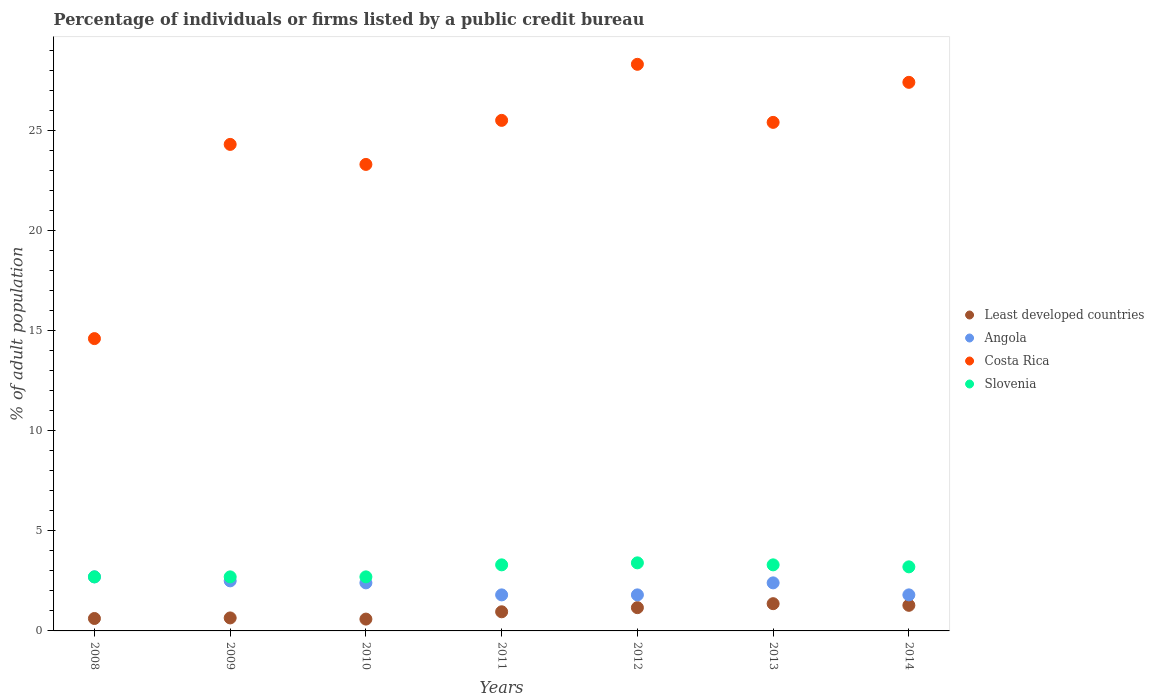How many different coloured dotlines are there?
Offer a very short reply. 4. Is the number of dotlines equal to the number of legend labels?
Keep it short and to the point. Yes. What is the percentage of population listed by a public credit bureau in Slovenia in 2009?
Provide a succinct answer. 2.7. Across all years, what is the maximum percentage of population listed by a public credit bureau in Slovenia?
Give a very brief answer. 3.4. Across all years, what is the minimum percentage of population listed by a public credit bureau in Slovenia?
Provide a succinct answer. 2.7. In which year was the percentage of population listed by a public credit bureau in Slovenia minimum?
Provide a short and direct response. 2008. What is the total percentage of population listed by a public credit bureau in Least developed countries in the graph?
Your answer should be compact. 6.62. What is the difference between the percentage of population listed by a public credit bureau in Slovenia in 2008 and that in 2012?
Your answer should be compact. -0.7. What is the difference between the percentage of population listed by a public credit bureau in Slovenia in 2011 and the percentage of population listed by a public credit bureau in Angola in 2008?
Keep it short and to the point. 0.6. What is the average percentage of population listed by a public credit bureau in Slovenia per year?
Provide a short and direct response. 3.04. In the year 2009, what is the difference between the percentage of population listed by a public credit bureau in Angola and percentage of population listed by a public credit bureau in Least developed countries?
Provide a short and direct response. 1.85. In how many years, is the percentage of population listed by a public credit bureau in Least developed countries greater than 5 %?
Provide a succinct answer. 0. What is the ratio of the percentage of population listed by a public credit bureau in Slovenia in 2011 to that in 2014?
Give a very brief answer. 1.03. Is the percentage of population listed by a public credit bureau in Angola in 2011 less than that in 2014?
Offer a terse response. No. Is the difference between the percentage of population listed by a public credit bureau in Angola in 2010 and 2014 greater than the difference between the percentage of population listed by a public credit bureau in Least developed countries in 2010 and 2014?
Provide a succinct answer. Yes. What is the difference between the highest and the second highest percentage of population listed by a public credit bureau in Costa Rica?
Ensure brevity in your answer.  0.9. What is the difference between the highest and the lowest percentage of population listed by a public credit bureau in Least developed countries?
Offer a very short reply. 0.77. Is it the case that in every year, the sum of the percentage of population listed by a public credit bureau in Angola and percentage of population listed by a public credit bureau in Costa Rica  is greater than the sum of percentage of population listed by a public credit bureau in Least developed countries and percentage of population listed by a public credit bureau in Slovenia?
Offer a terse response. Yes. Is it the case that in every year, the sum of the percentage of population listed by a public credit bureau in Angola and percentage of population listed by a public credit bureau in Costa Rica  is greater than the percentage of population listed by a public credit bureau in Slovenia?
Provide a succinct answer. Yes. Does the percentage of population listed by a public credit bureau in Slovenia monotonically increase over the years?
Offer a terse response. No. How many dotlines are there?
Provide a short and direct response. 4. How many years are there in the graph?
Provide a short and direct response. 7. What is the difference between two consecutive major ticks on the Y-axis?
Give a very brief answer. 5. Does the graph contain grids?
Keep it short and to the point. No. How are the legend labels stacked?
Provide a succinct answer. Vertical. What is the title of the graph?
Ensure brevity in your answer.  Percentage of individuals or firms listed by a public credit bureau. What is the label or title of the X-axis?
Offer a terse response. Years. What is the label or title of the Y-axis?
Provide a short and direct response. % of adult population. What is the % of adult population of Least developed countries in 2008?
Make the answer very short. 0.62. What is the % of adult population in Least developed countries in 2009?
Provide a short and direct response. 0.65. What is the % of adult population in Angola in 2009?
Make the answer very short. 2.5. What is the % of adult population of Costa Rica in 2009?
Make the answer very short. 24.3. What is the % of adult population in Slovenia in 2009?
Make the answer very short. 2.7. What is the % of adult population of Least developed countries in 2010?
Make the answer very short. 0.59. What is the % of adult population of Angola in 2010?
Provide a short and direct response. 2.4. What is the % of adult population in Costa Rica in 2010?
Give a very brief answer. 23.3. What is the % of adult population of Least developed countries in 2011?
Offer a terse response. 0.96. What is the % of adult population of Angola in 2011?
Your answer should be compact. 1.8. What is the % of adult population in Costa Rica in 2011?
Offer a terse response. 25.5. What is the % of adult population of Least developed countries in 2012?
Offer a very short reply. 1.16. What is the % of adult population of Costa Rica in 2012?
Your response must be concise. 28.3. What is the % of adult population of Least developed countries in 2013?
Your response must be concise. 1.36. What is the % of adult population in Costa Rica in 2013?
Offer a very short reply. 25.4. What is the % of adult population in Slovenia in 2013?
Give a very brief answer. 3.3. What is the % of adult population of Least developed countries in 2014?
Keep it short and to the point. 1.28. What is the % of adult population in Costa Rica in 2014?
Offer a terse response. 27.4. What is the % of adult population in Slovenia in 2014?
Your answer should be compact. 3.2. Across all years, what is the maximum % of adult population in Least developed countries?
Give a very brief answer. 1.36. Across all years, what is the maximum % of adult population of Costa Rica?
Give a very brief answer. 28.3. Across all years, what is the maximum % of adult population of Slovenia?
Your answer should be very brief. 3.4. Across all years, what is the minimum % of adult population in Least developed countries?
Offer a terse response. 0.59. Across all years, what is the minimum % of adult population in Costa Rica?
Ensure brevity in your answer.  14.6. Across all years, what is the minimum % of adult population of Slovenia?
Your answer should be very brief. 2.7. What is the total % of adult population of Least developed countries in the graph?
Offer a terse response. 6.62. What is the total % of adult population of Angola in the graph?
Offer a very short reply. 15.4. What is the total % of adult population in Costa Rica in the graph?
Offer a very short reply. 168.8. What is the total % of adult population in Slovenia in the graph?
Offer a terse response. 21.3. What is the difference between the % of adult population of Least developed countries in 2008 and that in 2009?
Ensure brevity in your answer.  -0.03. What is the difference between the % of adult population in Angola in 2008 and that in 2009?
Your answer should be compact. 0.2. What is the difference between the % of adult population of Slovenia in 2008 and that in 2009?
Provide a short and direct response. 0. What is the difference between the % of adult population of Least developed countries in 2008 and that in 2010?
Make the answer very short. 0.03. What is the difference between the % of adult population in Angola in 2008 and that in 2010?
Offer a terse response. 0.3. What is the difference between the % of adult population of Costa Rica in 2008 and that in 2010?
Your answer should be compact. -8.7. What is the difference between the % of adult population in Slovenia in 2008 and that in 2010?
Your answer should be very brief. 0. What is the difference between the % of adult population in Least developed countries in 2008 and that in 2011?
Your answer should be very brief. -0.33. What is the difference between the % of adult population in Least developed countries in 2008 and that in 2012?
Provide a short and direct response. -0.54. What is the difference between the % of adult population of Angola in 2008 and that in 2012?
Ensure brevity in your answer.  0.9. What is the difference between the % of adult population in Costa Rica in 2008 and that in 2012?
Offer a very short reply. -13.7. What is the difference between the % of adult population in Least developed countries in 2008 and that in 2013?
Make the answer very short. -0.74. What is the difference between the % of adult population of Angola in 2008 and that in 2013?
Offer a terse response. 0.3. What is the difference between the % of adult population of Least developed countries in 2008 and that in 2014?
Offer a very short reply. -0.66. What is the difference between the % of adult population of Angola in 2008 and that in 2014?
Ensure brevity in your answer.  0.9. What is the difference between the % of adult population in Costa Rica in 2008 and that in 2014?
Provide a succinct answer. -12.8. What is the difference between the % of adult population of Slovenia in 2008 and that in 2014?
Your answer should be very brief. -0.5. What is the difference between the % of adult population of Least developed countries in 2009 and that in 2010?
Keep it short and to the point. 0.06. What is the difference between the % of adult population of Angola in 2009 and that in 2010?
Make the answer very short. 0.1. What is the difference between the % of adult population in Slovenia in 2009 and that in 2010?
Provide a succinct answer. 0. What is the difference between the % of adult population of Least developed countries in 2009 and that in 2011?
Keep it short and to the point. -0.31. What is the difference between the % of adult population in Costa Rica in 2009 and that in 2011?
Your answer should be very brief. -1.2. What is the difference between the % of adult population in Slovenia in 2009 and that in 2011?
Your response must be concise. -0.6. What is the difference between the % of adult population in Least developed countries in 2009 and that in 2012?
Give a very brief answer. -0.51. What is the difference between the % of adult population of Costa Rica in 2009 and that in 2012?
Keep it short and to the point. -4. What is the difference between the % of adult population in Slovenia in 2009 and that in 2012?
Offer a terse response. -0.7. What is the difference between the % of adult population of Least developed countries in 2009 and that in 2013?
Your answer should be very brief. -0.71. What is the difference between the % of adult population of Costa Rica in 2009 and that in 2013?
Make the answer very short. -1.1. What is the difference between the % of adult population of Slovenia in 2009 and that in 2013?
Make the answer very short. -0.6. What is the difference between the % of adult population of Least developed countries in 2009 and that in 2014?
Offer a terse response. -0.63. What is the difference between the % of adult population of Slovenia in 2009 and that in 2014?
Your response must be concise. -0.5. What is the difference between the % of adult population of Least developed countries in 2010 and that in 2011?
Offer a very short reply. -0.37. What is the difference between the % of adult population in Angola in 2010 and that in 2011?
Offer a terse response. 0.6. What is the difference between the % of adult population of Least developed countries in 2010 and that in 2012?
Give a very brief answer. -0.57. What is the difference between the % of adult population in Angola in 2010 and that in 2012?
Offer a terse response. 0.6. What is the difference between the % of adult population of Slovenia in 2010 and that in 2012?
Make the answer very short. -0.7. What is the difference between the % of adult population of Least developed countries in 2010 and that in 2013?
Your answer should be very brief. -0.77. What is the difference between the % of adult population of Least developed countries in 2010 and that in 2014?
Your answer should be very brief. -0.69. What is the difference between the % of adult population of Angola in 2010 and that in 2014?
Offer a very short reply. 0.6. What is the difference between the % of adult population of Costa Rica in 2010 and that in 2014?
Provide a short and direct response. -4.1. What is the difference between the % of adult population in Least developed countries in 2011 and that in 2012?
Keep it short and to the point. -0.21. What is the difference between the % of adult population of Costa Rica in 2011 and that in 2012?
Ensure brevity in your answer.  -2.8. What is the difference between the % of adult population of Least developed countries in 2011 and that in 2013?
Provide a short and direct response. -0.41. What is the difference between the % of adult population of Costa Rica in 2011 and that in 2013?
Provide a succinct answer. 0.1. What is the difference between the % of adult population of Slovenia in 2011 and that in 2013?
Keep it short and to the point. 0. What is the difference between the % of adult population in Least developed countries in 2011 and that in 2014?
Make the answer very short. -0.32. What is the difference between the % of adult population of Least developed countries in 2012 and that in 2013?
Your answer should be very brief. -0.2. What is the difference between the % of adult population of Slovenia in 2012 and that in 2013?
Your response must be concise. 0.1. What is the difference between the % of adult population in Least developed countries in 2012 and that in 2014?
Make the answer very short. -0.12. What is the difference between the % of adult population of Costa Rica in 2012 and that in 2014?
Provide a succinct answer. 0.9. What is the difference between the % of adult population of Least developed countries in 2013 and that in 2014?
Make the answer very short. 0.08. What is the difference between the % of adult population of Angola in 2013 and that in 2014?
Keep it short and to the point. 0.6. What is the difference between the % of adult population of Least developed countries in 2008 and the % of adult population of Angola in 2009?
Your answer should be very brief. -1.88. What is the difference between the % of adult population of Least developed countries in 2008 and the % of adult population of Costa Rica in 2009?
Your answer should be very brief. -23.68. What is the difference between the % of adult population in Least developed countries in 2008 and the % of adult population in Slovenia in 2009?
Offer a terse response. -2.08. What is the difference between the % of adult population in Angola in 2008 and the % of adult population in Costa Rica in 2009?
Give a very brief answer. -21.6. What is the difference between the % of adult population of Angola in 2008 and the % of adult population of Slovenia in 2009?
Provide a short and direct response. 0. What is the difference between the % of adult population in Least developed countries in 2008 and the % of adult population in Angola in 2010?
Your answer should be very brief. -1.78. What is the difference between the % of adult population in Least developed countries in 2008 and the % of adult population in Costa Rica in 2010?
Give a very brief answer. -22.68. What is the difference between the % of adult population in Least developed countries in 2008 and the % of adult population in Slovenia in 2010?
Offer a very short reply. -2.08. What is the difference between the % of adult population in Angola in 2008 and the % of adult population in Costa Rica in 2010?
Your response must be concise. -20.6. What is the difference between the % of adult population of Least developed countries in 2008 and the % of adult population of Angola in 2011?
Your response must be concise. -1.18. What is the difference between the % of adult population of Least developed countries in 2008 and the % of adult population of Costa Rica in 2011?
Offer a terse response. -24.88. What is the difference between the % of adult population in Least developed countries in 2008 and the % of adult population in Slovenia in 2011?
Give a very brief answer. -2.68. What is the difference between the % of adult population in Angola in 2008 and the % of adult population in Costa Rica in 2011?
Your answer should be compact. -22.8. What is the difference between the % of adult population in Angola in 2008 and the % of adult population in Slovenia in 2011?
Provide a succinct answer. -0.6. What is the difference between the % of adult population in Least developed countries in 2008 and the % of adult population in Angola in 2012?
Ensure brevity in your answer.  -1.18. What is the difference between the % of adult population in Least developed countries in 2008 and the % of adult population in Costa Rica in 2012?
Ensure brevity in your answer.  -27.68. What is the difference between the % of adult population in Least developed countries in 2008 and the % of adult population in Slovenia in 2012?
Your answer should be compact. -2.78. What is the difference between the % of adult population of Angola in 2008 and the % of adult population of Costa Rica in 2012?
Keep it short and to the point. -25.6. What is the difference between the % of adult population of Angola in 2008 and the % of adult population of Slovenia in 2012?
Ensure brevity in your answer.  -0.7. What is the difference between the % of adult population of Costa Rica in 2008 and the % of adult population of Slovenia in 2012?
Provide a succinct answer. 11.2. What is the difference between the % of adult population in Least developed countries in 2008 and the % of adult population in Angola in 2013?
Offer a very short reply. -1.78. What is the difference between the % of adult population in Least developed countries in 2008 and the % of adult population in Costa Rica in 2013?
Your answer should be compact. -24.78. What is the difference between the % of adult population of Least developed countries in 2008 and the % of adult population of Slovenia in 2013?
Offer a terse response. -2.68. What is the difference between the % of adult population of Angola in 2008 and the % of adult population of Costa Rica in 2013?
Keep it short and to the point. -22.7. What is the difference between the % of adult population of Angola in 2008 and the % of adult population of Slovenia in 2013?
Ensure brevity in your answer.  -0.6. What is the difference between the % of adult population of Costa Rica in 2008 and the % of adult population of Slovenia in 2013?
Provide a short and direct response. 11.3. What is the difference between the % of adult population of Least developed countries in 2008 and the % of adult population of Angola in 2014?
Your response must be concise. -1.18. What is the difference between the % of adult population in Least developed countries in 2008 and the % of adult population in Costa Rica in 2014?
Offer a terse response. -26.78. What is the difference between the % of adult population in Least developed countries in 2008 and the % of adult population in Slovenia in 2014?
Ensure brevity in your answer.  -2.58. What is the difference between the % of adult population in Angola in 2008 and the % of adult population in Costa Rica in 2014?
Offer a terse response. -24.7. What is the difference between the % of adult population in Angola in 2008 and the % of adult population in Slovenia in 2014?
Provide a succinct answer. -0.5. What is the difference between the % of adult population of Costa Rica in 2008 and the % of adult population of Slovenia in 2014?
Provide a short and direct response. 11.4. What is the difference between the % of adult population in Least developed countries in 2009 and the % of adult population in Angola in 2010?
Your answer should be compact. -1.75. What is the difference between the % of adult population of Least developed countries in 2009 and the % of adult population of Costa Rica in 2010?
Your response must be concise. -22.65. What is the difference between the % of adult population of Least developed countries in 2009 and the % of adult population of Slovenia in 2010?
Give a very brief answer. -2.05. What is the difference between the % of adult population in Angola in 2009 and the % of adult population in Costa Rica in 2010?
Your answer should be compact. -20.8. What is the difference between the % of adult population in Costa Rica in 2009 and the % of adult population in Slovenia in 2010?
Make the answer very short. 21.6. What is the difference between the % of adult population of Least developed countries in 2009 and the % of adult population of Angola in 2011?
Give a very brief answer. -1.15. What is the difference between the % of adult population in Least developed countries in 2009 and the % of adult population in Costa Rica in 2011?
Offer a terse response. -24.85. What is the difference between the % of adult population of Least developed countries in 2009 and the % of adult population of Slovenia in 2011?
Your response must be concise. -2.65. What is the difference between the % of adult population of Angola in 2009 and the % of adult population of Costa Rica in 2011?
Provide a short and direct response. -23. What is the difference between the % of adult population of Costa Rica in 2009 and the % of adult population of Slovenia in 2011?
Your response must be concise. 21. What is the difference between the % of adult population of Least developed countries in 2009 and the % of adult population of Angola in 2012?
Keep it short and to the point. -1.15. What is the difference between the % of adult population in Least developed countries in 2009 and the % of adult population in Costa Rica in 2012?
Provide a succinct answer. -27.65. What is the difference between the % of adult population of Least developed countries in 2009 and the % of adult population of Slovenia in 2012?
Provide a succinct answer. -2.75. What is the difference between the % of adult population of Angola in 2009 and the % of adult population of Costa Rica in 2012?
Ensure brevity in your answer.  -25.8. What is the difference between the % of adult population of Costa Rica in 2009 and the % of adult population of Slovenia in 2012?
Keep it short and to the point. 20.9. What is the difference between the % of adult population in Least developed countries in 2009 and the % of adult population in Angola in 2013?
Your answer should be very brief. -1.75. What is the difference between the % of adult population of Least developed countries in 2009 and the % of adult population of Costa Rica in 2013?
Offer a terse response. -24.75. What is the difference between the % of adult population of Least developed countries in 2009 and the % of adult population of Slovenia in 2013?
Your answer should be compact. -2.65. What is the difference between the % of adult population in Angola in 2009 and the % of adult population in Costa Rica in 2013?
Provide a short and direct response. -22.9. What is the difference between the % of adult population of Angola in 2009 and the % of adult population of Slovenia in 2013?
Your answer should be very brief. -0.8. What is the difference between the % of adult population in Least developed countries in 2009 and the % of adult population in Angola in 2014?
Your answer should be compact. -1.15. What is the difference between the % of adult population in Least developed countries in 2009 and the % of adult population in Costa Rica in 2014?
Provide a short and direct response. -26.75. What is the difference between the % of adult population of Least developed countries in 2009 and the % of adult population of Slovenia in 2014?
Your answer should be very brief. -2.55. What is the difference between the % of adult population in Angola in 2009 and the % of adult population in Costa Rica in 2014?
Provide a succinct answer. -24.9. What is the difference between the % of adult population of Costa Rica in 2009 and the % of adult population of Slovenia in 2014?
Your response must be concise. 21.1. What is the difference between the % of adult population of Least developed countries in 2010 and the % of adult population of Angola in 2011?
Your answer should be compact. -1.21. What is the difference between the % of adult population of Least developed countries in 2010 and the % of adult population of Costa Rica in 2011?
Make the answer very short. -24.91. What is the difference between the % of adult population in Least developed countries in 2010 and the % of adult population in Slovenia in 2011?
Provide a succinct answer. -2.71. What is the difference between the % of adult population in Angola in 2010 and the % of adult population in Costa Rica in 2011?
Provide a succinct answer. -23.1. What is the difference between the % of adult population of Angola in 2010 and the % of adult population of Slovenia in 2011?
Offer a very short reply. -0.9. What is the difference between the % of adult population in Costa Rica in 2010 and the % of adult population in Slovenia in 2011?
Provide a short and direct response. 20. What is the difference between the % of adult population of Least developed countries in 2010 and the % of adult population of Angola in 2012?
Your answer should be very brief. -1.21. What is the difference between the % of adult population in Least developed countries in 2010 and the % of adult population in Costa Rica in 2012?
Your response must be concise. -27.71. What is the difference between the % of adult population of Least developed countries in 2010 and the % of adult population of Slovenia in 2012?
Provide a succinct answer. -2.81. What is the difference between the % of adult population in Angola in 2010 and the % of adult population in Costa Rica in 2012?
Provide a succinct answer. -25.9. What is the difference between the % of adult population of Angola in 2010 and the % of adult population of Slovenia in 2012?
Your answer should be compact. -1. What is the difference between the % of adult population of Least developed countries in 2010 and the % of adult population of Angola in 2013?
Offer a terse response. -1.81. What is the difference between the % of adult population in Least developed countries in 2010 and the % of adult population in Costa Rica in 2013?
Offer a very short reply. -24.81. What is the difference between the % of adult population in Least developed countries in 2010 and the % of adult population in Slovenia in 2013?
Offer a terse response. -2.71. What is the difference between the % of adult population in Least developed countries in 2010 and the % of adult population in Angola in 2014?
Provide a short and direct response. -1.21. What is the difference between the % of adult population in Least developed countries in 2010 and the % of adult population in Costa Rica in 2014?
Your answer should be very brief. -26.81. What is the difference between the % of adult population of Least developed countries in 2010 and the % of adult population of Slovenia in 2014?
Give a very brief answer. -2.61. What is the difference between the % of adult population of Angola in 2010 and the % of adult population of Costa Rica in 2014?
Give a very brief answer. -25. What is the difference between the % of adult population of Angola in 2010 and the % of adult population of Slovenia in 2014?
Provide a short and direct response. -0.8. What is the difference between the % of adult population of Costa Rica in 2010 and the % of adult population of Slovenia in 2014?
Provide a short and direct response. 20.1. What is the difference between the % of adult population in Least developed countries in 2011 and the % of adult population in Angola in 2012?
Ensure brevity in your answer.  -0.84. What is the difference between the % of adult population of Least developed countries in 2011 and the % of adult population of Costa Rica in 2012?
Keep it short and to the point. -27.34. What is the difference between the % of adult population of Least developed countries in 2011 and the % of adult population of Slovenia in 2012?
Provide a succinct answer. -2.44. What is the difference between the % of adult population in Angola in 2011 and the % of adult population in Costa Rica in 2012?
Make the answer very short. -26.5. What is the difference between the % of adult population in Costa Rica in 2011 and the % of adult population in Slovenia in 2012?
Make the answer very short. 22.1. What is the difference between the % of adult population of Least developed countries in 2011 and the % of adult population of Angola in 2013?
Make the answer very short. -1.44. What is the difference between the % of adult population in Least developed countries in 2011 and the % of adult population in Costa Rica in 2013?
Your answer should be very brief. -24.44. What is the difference between the % of adult population in Least developed countries in 2011 and the % of adult population in Slovenia in 2013?
Offer a terse response. -2.34. What is the difference between the % of adult population of Angola in 2011 and the % of adult population of Costa Rica in 2013?
Keep it short and to the point. -23.6. What is the difference between the % of adult population in Costa Rica in 2011 and the % of adult population in Slovenia in 2013?
Offer a terse response. 22.2. What is the difference between the % of adult population in Least developed countries in 2011 and the % of adult population in Angola in 2014?
Ensure brevity in your answer.  -0.84. What is the difference between the % of adult population of Least developed countries in 2011 and the % of adult population of Costa Rica in 2014?
Provide a short and direct response. -26.44. What is the difference between the % of adult population in Least developed countries in 2011 and the % of adult population in Slovenia in 2014?
Provide a succinct answer. -2.24. What is the difference between the % of adult population in Angola in 2011 and the % of adult population in Costa Rica in 2014?
Provide a short and direct response. -25.6. What is the difference between the % of adult population of Angola in 2011 and the % of adult population of Slovenia in 2014?
Offer a very short reply. -1.4. What is the difference between the % of adult population in Costa Rica in 2011 and the % of adult population in Slovenia in 2014?
Make the answer very short. 22.3. What is the difference between the % of adult population in Least developed countries in 2012 and the % of adult population in Angola in 2013?
Provide a short and direct response. -1.24. What is the difference between the % of adult population of Least developed countries in 2012 and the % of adult population of Costa Rica in 2013?
Your answer should be very brief. -24.24. What is the difference between the % of adult population in Least developed countries in 2012 and the % of adult population in Slovenia in 2013?
Your answer should be very brief. -2.14. What is the difference between the % of adult population of Angola in 2012 and the % of adult population of Costa Rica in 2013?
Offer a very short reply. -23.6. What is the difference between the % of adult population in Angola in 2012 and the % of adult population in Slovenia in 2013?
Your answer should be very brief. -1.5. What is the difference between the % of adult population of Least developed countries in 2012 and the % of adult population of Angola in 2014?
Provide a short and direct response. -0.64. What is the difference between the % of adult population in Least developed countries in 2012 and the % of adult population in Costa Rica in 2014?
Your answer should be very brief. -26.24. What is the difference between the % of adult population in Least developed countries in 2012 and the % of adult population in Slovenia in 2014?
Ensure brevity in your answer.  -2.04. What is the difference between the % of adult population of Angola in 2012 and the % of adult population of Costa Rica in 2014?
Your answer should be very brief. -25.6. What is the difference between the % of adult population in Costa Rica in 2012 and the % of adult population in Slovenia in 2014?
Your response must be concise. 25.1. What is the difference between the % of adult population in Least developed countries in 2013 and the % of adult population in Angola in 2014?
Offer a very short reply. -0.44. What is the difference between the % of adult population of Least developed countries in 2013 and the % of adult population of Costa Rica in 2014?
Make the answer very short. -26.04. What is the difference between the % of adult population of Least developed countries in 2013 and the % of adult population of Slovenia in 2014?
Give a very brief answer. -1.84. What is the difference between the % of adult population in Angola in 2013 and the % of adult population in Costa Rica in 2014?
Provide a succinct answer. -25. What is the difference between the % of adult population of Costa Rica in 2013 and the % of adult population of Slovenia in 2014?
Provide a succinct answer. 22.2. What is the average % of adult population of Least developed countries per year?
Ensure brevity in your answer.  0.95. What is the average % of adult population in Costa Rica per year?
Provide a succinct answer. 24.11. What is the average % of adult population in Slovenia per year?
Provide a short and direct response. 3.04. In the year 2008, what is the difference between the % of adult population of Least developed countries and % of adult population of Angola?
Your answer should be very brief. -2.08. In the year 2008, what is the difference between the % of adult population of Least developed countries and % of adult population of Costa Rica?
Provide a succinct answer. -13.98. In the year 2008, what is the difference between the % of adult population of Least developed countries and % of adult population of Slovenia?
Offer a terse response. -2.08. In the year 2008, what is the difference between the % of adult population in Angola and % of adult population in Costa Rica?
Your answer should be compact. -11.9. In the year 2008, what is the difference between the % of adult population in Angola and % of adult population in Slovenia?
Give a very brief answer. 0. In the year 2009, what is the difference between the % of adult population in Least developed countries and % of adult population in Angola?
Keep it short and to the point. -1.85. In the year 2009, what is the difference between the % of adult population of Least developed countries and % of adult population of Costa Rica?
Provide a short and direct response. -23.65. In the year 2009, what is the difference between the % of adult population of Least developed countries and % of adult population of Slovenia?
Your response must be concise. -2.05. In the year 2009, what is the difference between the % of adult population of Angola and % of adult population of Costa Rica?
Offer a very short reply. -21.8. In the year 2009, what is the difference between the % of adult population in Costa Rica and % of adult population in Slovenia?
Your response must be concise. 21.6. In the year 2010, what is the difference between the % of adult population of Least developed countries and % of adult population of Angola?
Give a very brief answer. -1.81. In the year 2010, what is the difference between the % of adult population in Least developed countries and % of adult population in Costa Rica?
Keep it short and to the point. -22.71. In the year 2010, what is the difference between the % of adult population in Least developed countries and % of adult population in Slovenia?
Your response must be concise. -2.11. In the year 2010, what is the difference between the % of adult population in Angola and % of adult population in Costa Rica?
Provide a succinct answer. -20.9. In the year 2010, what is the difference between the % of adult population in Costa Rica and % of adult population in Slovenia?
Provide a short and direct response. 20.6. In the year 2011, what is the difference between the % of adult population in Least developed countries and % of adult population in Angola?
Offer a very short reply. -0.84. In the year 2011, what is the difference between the % of adult population of Least developed countries and % of adult population of Costa Rica?
Offer a terse response. -24.54. In the year 2011, what is the difference between the % of adult population of Least developed countries and % of adult population of Slovenia?
Your answer should be compact. -2.34. In the year 2011, what is the difference between the % of adult population in Angola and % of adult population in Costa Rica?
Give a very brief answer. -23.7. In the year 2012, what is the difference between the % of adult population of Least developed countries and % of adult population of Angola?
Provide a succinct answer. -0.64. In the year 2012, what is the difference between the % of adult population in Least developed countries and % of adult population in Costa Rica?
Keep it short and to the point. -27.14. In the year 2012, what is the difference between the % of adult population of Least developed countries and % of adult population of Slovenia?
Provide a short and direct response. -2.24. In the year 2012, what is the difference between the % of adult population of Angola and % of adult population of Costa Rica?
Your answer should be compact. -26.5. In the year 2012, what is the difference between the % of adult population in Angola and % of adult population in Slovenia?
Give a very brief answer. -1.6. In the year 2012, what is the difference between the % of adult population of Costa Rica and % of adult population of Slovenia?
Your answer should be compact. 24.9. In the year 2013, what is the difference between the % of adult population of Least developed countries and % of adult population of Angola?
Keep it short and to the point. -1.04. In the year 2013, what is the difference between the % of adult population of Least developed countries and % of adult population of Costa Rica?
Keep it short and to the point. -24.04. In the year 2013, what is the difference between the % of adult population in Least developed countries and % of adult population in Slovenia?
Your response must be concise. -1.94. In the year 2013, what is the difference between the % of adult population of Costa Rica and % of adult population of Slovenia?
Your answer should be compact. 22.1. In the year 2014, what is the difference between the % of adult population of Least developed countries and % of adult population of Angola?
Give a very brief answer. -0.52. In the year 2014, what is the difference between the % of adult population in Least developed countries and % of adult population in Costa Rica?
Provide a short and direct response. -26.12. In the year 2014, what is the difference between the % of adult population in Least developed countries and % of adult population in Slovenia?
Your answer should be compact. -1.92. In the year 2014, what is the difference between the % of adult population of Angola and % of adult population of Costa Rica?
Make the answer very short. -25.6. In the year 2014, what is the difference between the % of adult population in Costa Rica and % of adult population in Slovenia?
Your answer should be compact. 24.2. What is the ratio of the % of adult population of Angola in 2008 to that in 2009?
Your response must be concise. 1.08. What is the ratio of the % of adult population of Costa Rica in 2008 to that in 2009?
Make the answer very short. 0.6. What is the ratio of the % of adult population in Least developed countries in 2008 to that in 2010?
Your response must be concise. 1.05. What is the ratio of the % of adult population in Costa Rica in 2008 to that in 2010?
Your response must be concise. 0.63. What is the ratio of the % of adult population of Least developed countries in 2008 to that in 2011?
Make the answer very short. 0.65. What is the ratio of the % of adult population of Angola in 2008 to that in 2011?
Provide a short and direct response. 1.5. What is the ratio of the % of adult population of Costa Rica in 2008 to that in 2011?
Provide a short and direct response. 0.57. What is the ratio of the % of adult population of Slovenia in 2008 to that in 2011?
Provide a short and direct response. 0.82. What is the ratio of the % of adult population in Least developed countries in 2008 to that in 2012?
Your answer should be compact. 0.53. What is the ratio of the % of adult population in Costa Rica in 2008 to that in 2012?
Give a very brief answer. 0.52. What is the ratio of the % of adult population of Slovenia in 2008 to that in 2012?
Offer a very short reply. 0.79. What is the ratio of the % of adult population in Least developed countries in 2008 to that in 2013?
Ensure brevity in your answer.  0.46. What is the ratio of the % of adult population in Angola in 2008 to that in 2013?
Provide a short and direct response. 1.12. What is the ratio of the % of adult population in Costa Rica in 2008 to that in 2013?
Keep it short and to the point. 0.57. What is the ratio of the % of adult population in Slovenia in 2008 to that in 2013?
Your response must be concise. 0.82. What is the ratio of the % of adult population of Least developed countries in 2008 to that in 2014?
Offer a terse response. 0.49. What is the ratio of the % of adult population of Angola in 2008 to that in 2014?
Make the answer very short. 1.5. What is the ratio of the % of adult population of Costa Rica in 2008 to that in 2014?
Make the answer very short. 0.53. What is the ratio of the % of adult population of Slovenia in 2008 to that in 2014?
Ensure brevity in your answer.  0.84. What is the ratio of the % of adult population of Least developed countries in 2009 to that in 2010?
Offer a terse response. 1.1. What is the ratio of the % of adult population of Angola in 2009 to that in 2010?
Your answer should be very brief. 1.04. What is the ratio of the % of adult population of Costa Rica in 2009 to that in 2010?
Make the answer very short. 1.04. What is the ratio of the % of adult population in Slovenia in 2009 to that in 2010?
Your answer should be very brief. 1. What is the ratio of the % of adult population of Least developed countries in 2009 to that in 2011?
Your answer should be very brief. 0.68. What is the ratio of the % of adult population in Angola in 2009 to that in 2011?
Give a very brief answer. 1.39. What is the ratio of the % of adult population of Costa Rica in 2009 to that in 2011?
Keep it short and to the point. 0.95. What is the ratio of the % of adult population in Slovenia in 2009 to that in 2011?
Ensure brevity in your answer.  0.82. What is the ratio of the % of adult population in Least developed countries in 2009 to that in 2012?
Make the answer very short. 0.56. What is the ratio of the % of adult population in Angola in 2009 to that in 2012?
Provide a succinct answer. 1.39. What is the ratio of the % of adult population of Costa Rica in 2009 to that in 2012?
Offer a very short reply. 0.86. What is the ratio of the % of adult population in Slovenia in 2009 to that in 2012?
Provide a succinct answer. 0.79. What is the ratio of the % of adult population of Least developed countries in 2009 to that in 2013?
Give a very brief answer. 0.48. What is the ratio of the % of adult population of Angola in 2009 to that in 2013?
Offer a terse response. 1.04. What is the ratio of the % of adult population of Costa Rica in 2009 to that in 2013?
Keep it short and to the point. 0.96. What is the ratio of the % of adult population in Slovenia in 2009 to that in 2013?
Give a very brief answer. 0.82. What is the ratio of the % of adult population in Least developed countries in 2009 to that in 2014?
Your response must be concise. 0.51. What is the ratio of the % of adult population in Angola in 2009 to that in 2014?
Your response must be concise. 1.39. What is the ratio of the % of adult population of Costa Rica in 2009 to that in 2014?
Offer a terse response. 0.89. What is the ratio of the % of adult population in Slovenia in 2009 to that in 2014?
Offer a very short reply. 0.84. What is the ratio of the % of adult population in Least developed countries in 2010 to that in 2011?
Ensure brevity in your answer.  0.62. What is the ratio of the % of adult population in Angola in 2010 to that in 2011?
Ensure brevity in your answer.  1.33. What is the ratio of the % of adult population in Costa Rica in 2010 to that in 2011?
Your response must be concise. 0.91. What is the ratio of the % of adult population of Slovenia in 2010 to that in 2011?
Offer a terse response. 0.82. What is the ratio of the % of adult population in Least developed countries in 2010 to that in 2012?
Your answer should be very brief. 0.51. What is the ratio of the % of adult population in Angola in 2010 to that in 2012?
Keep it short and to the point. 1.33. What is the ratio of the % of adult population in Costa Rica in 2010 to that in 2012?
Keep it short and to the point. 0.82. What is the ratio of the % of adult population of Slovenia in 2010 to that in 2012?
Make the answer very short. 0.79. What is the ratio of the % of adult population in Least developed countries in 2010 to that in 2013?
Your response must be concise. 0.43. What is the ratio of the % of adult population of Costa Rica in 2010 to that in 2013?
Ensure brevity in your answer.  0.92. What is the ratio of the % of adult population of Slovenia in 2010 to that in 2013?
Make the answer very short. 0.82. What is the ratio of the % of adult population of Least developed countries in 2010 to that in 2014?
Make the answer very short. 0.46. What is the ratio of the % of adult population in Angola in 2010 to that in 2014?
Ensure brevity in your answer.  1.33. What is the ratio of the % of adult population of Costa Rica in 2010 to that in 2014?
Ensure brevity in your answer.  0.85. What is the ratio of the % of adult population in Slovenia in 2010 to that in 2014?
Your response must be concise. 0.84. What is the ratio of the % of adult population of Least developed countries in 2011 to that in 2012?
Your answer should be compact. 0.82. What is the ratio of the % of adult population in Angola in 2011 to that in 2012?
Provide a short and direct response. 1. What is the ratio of the % of adult population in Costa Rica in 2011 to that in 2012?
Make the answer very short. 0.9. What is the ratio of the % of adult population of Slovenia in 2011 to that in 2012?
Give a very brief answer. 0.97. What is the ratio of the % of adult population of Least developed countries in 2011 to that in 2013?
Your answer should be compact. 0.7. What is the ratio of the % of adult population in Slovenia in 2011 to that in 2013?
Ensure brevity in your answer.  1. What is the ratio of the % of adult population of Least developed countries in 2011 to that in 2014?
Your response must be concise. 0.75. What is the ratio of the % of adult population in Angola in 2011 to that in 2014?
Provide a succinct answer. 1. What is the ratio of the % of adult population of Costa Rica in 2011 to that in 2014?
Keep it short and to the point. 0.93. What is the ratio of the % of adult population of Slovenia in 2011 to that in 2014?
Provide a succinct answer. 1.03. What is the ratio of the % of adult population in Least developed countries in 2012 to that in 2013?
Make the answer very short. 0.85. What is the ratio of the % of adult population in Angola in 2012 to that in 2013?
Offer a very short reply. 0.75. What is the ratio of the % of adult population in Costa Rica in 2012 to that in 2013?
Your response must be concise. 1.11. What is the ratio of the % of adult population in Slovenia in 2012 to that in 2013?
Offer a terse response. 1.03. What is the ratio of the % of adult population in Least developed countries in 2012 to that in 2014?
Give a very brief answer. 0.91. What is the ratio of the % of adult population of Angola in 2012 to that in 2014?
Make the answer very short. 1. What is the ratio of the % of adult population in Costa Rica in 2012 to that in 2014?
Offer a terse response. 1.03. What is the ratio of the % of adult population of Least developed countries in 2013 to that in 2014?
Ensure brevity in your answer.  1.06. What is the ratio of the % of adult population in Costa Rica in 2013 to that in 2014?
Keep it short and to the point. 0.93. What is the ratio of the % of adult population in Slovenia in 2013 to that in 2014?
Offer a very short reply. 1.03. What is the difference between the highest and the second highest % of adult population of Least developed countries?
Keep it short and to the point. 0.08. What is the difference between the highest and the second highest % of adult population of Angola?
Ensure brevity in your answer.  0.2. What is the difference between the highest and the second highest % of adult population of Slovenia?
Offer a terse response. 0.1. What is the difference between the highest and the lowest % of adult population of Least developed countries?
Provide a succinct answer. 0.77. 